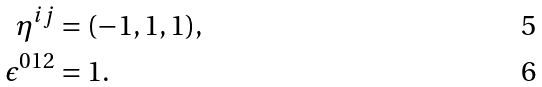<formula> <loc_0><loc_0><loc_500><loc_500>\eta ^ { i j } & = ( - 1 , 1 , 1 ) , \\ \epsilon ^ { 0 1 2 } & = 1 .</formula> 